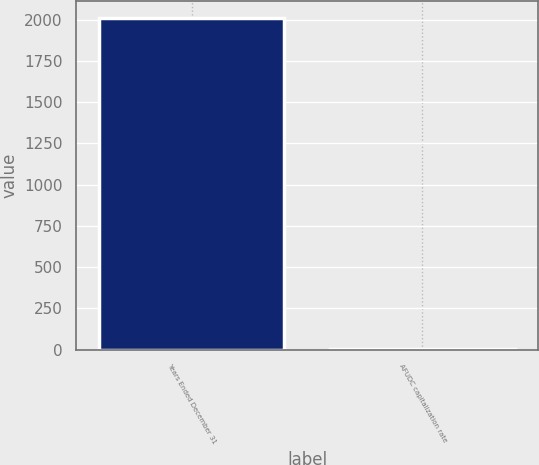Convert chart to OTSL. <chart><loc_0><loc_0><loc_500><loc_500><bar_chart><fcel>Years Ended December 31<fcel>AFUDC capitalization rate<nl><fcel>2013<fcel>7.3<nl></chart> 